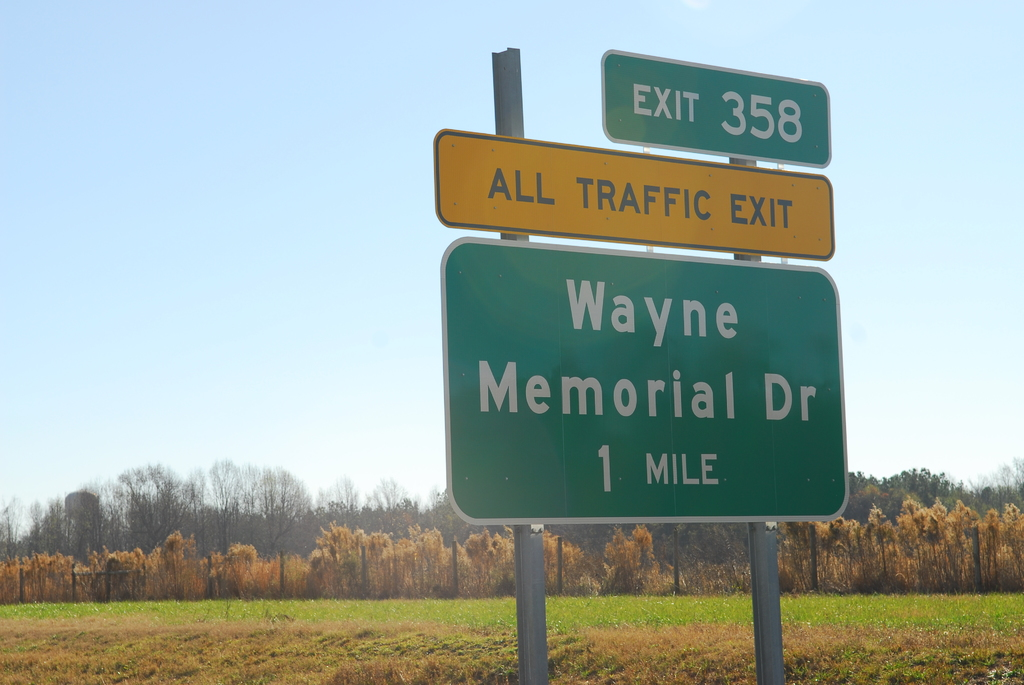What do you see happening in this image? The image features a highway scene with a distinct green exit sign prominently displayed. This sign indicates that exit 358, Wayne Memorial Drive, is one mile ahead, and notably mandates 'ALL TRAFFIC EXIT.' Such a message may suggest construction, special event traffic direction, or changes in the road ahead leading to a detour. The image captures a sunny day with clear skies and a natural landscape in the backdrop, setting a peaceful yet directive atmosphere along this road stretch. 